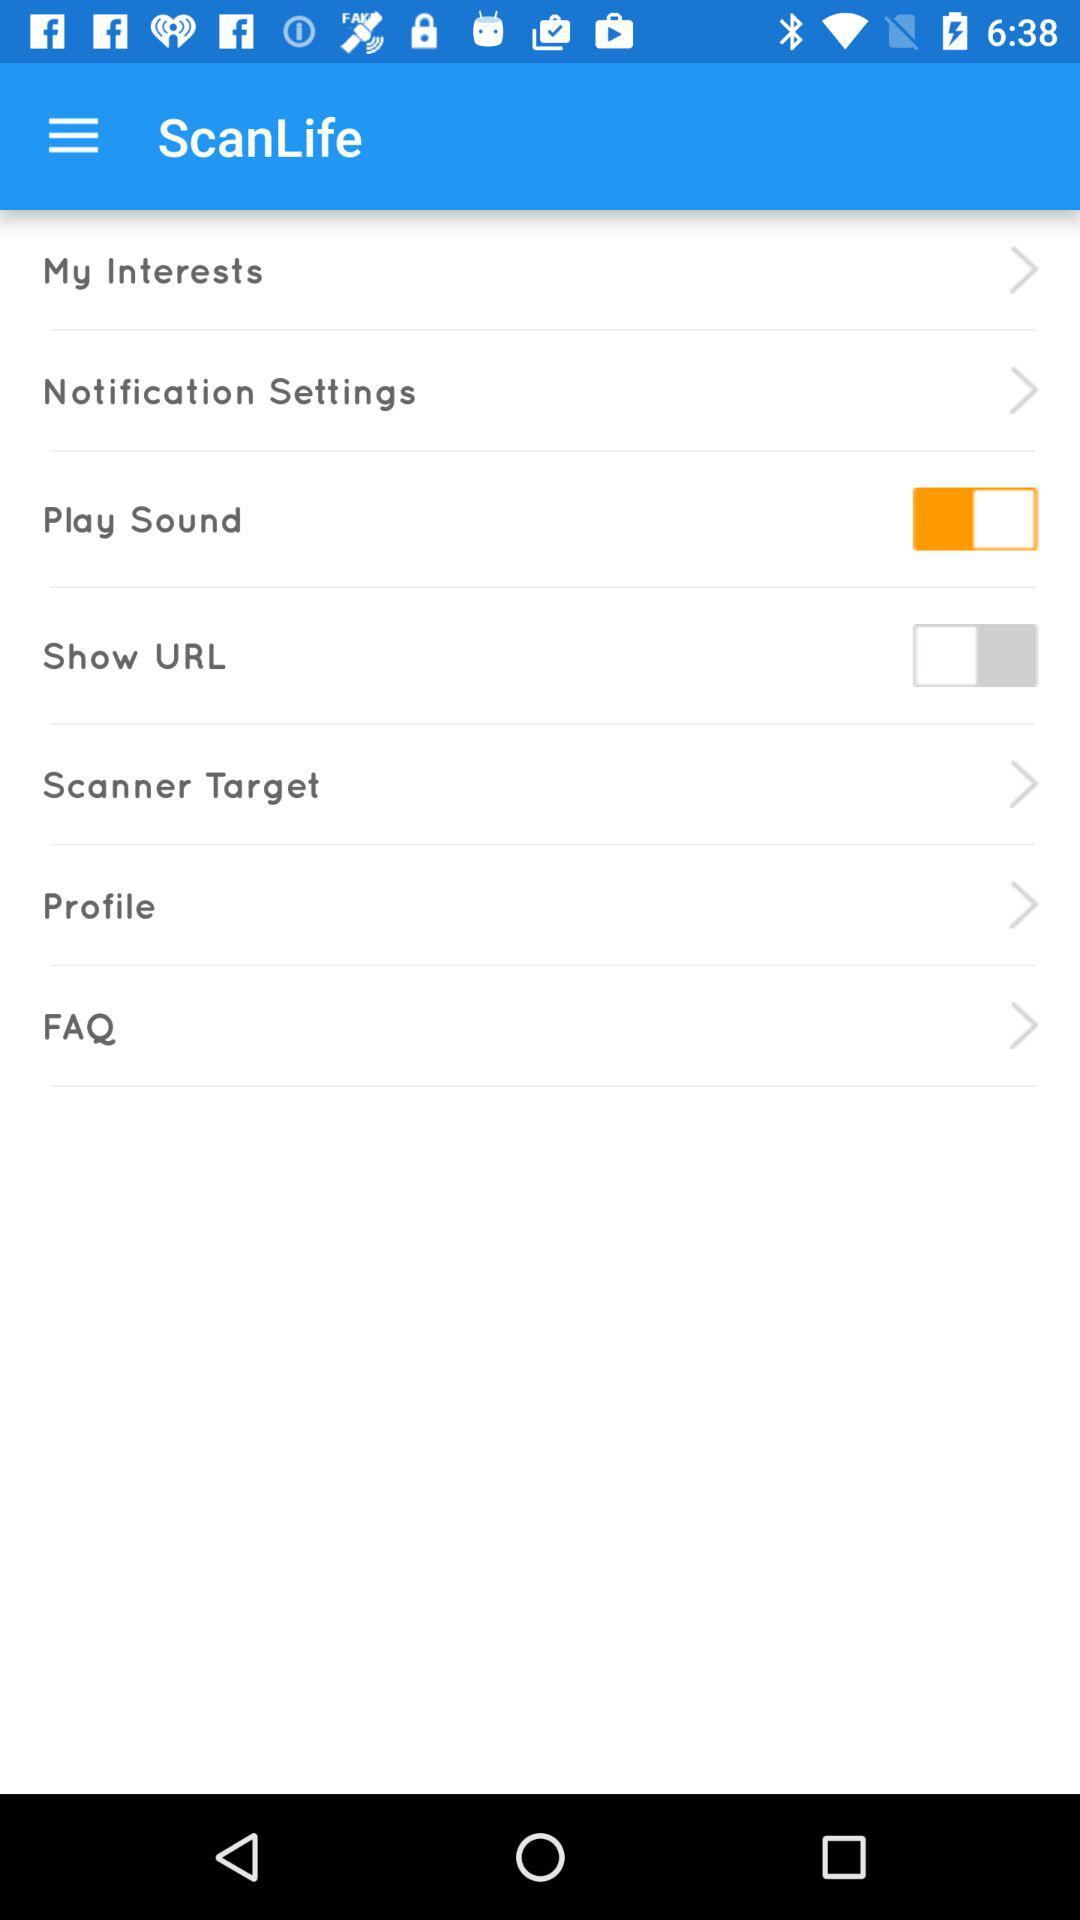How many items have a switch?
Answer the question using a single word or phrase. 2 